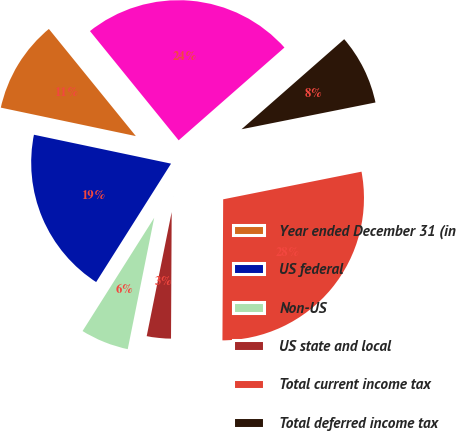<chart> <loc_0><loc_0><loc_500><loc_500><pie_chart><fcel>Year ended December 31 (in<fcel>US federal<fcel>Non-US<fcel>US state and local<fcel>Total current income tax<fcel>Total deferred income tax<fcel>Total income tax expense<nl><fcel>10.84%<fcel>19.33%<fcel>5.81%<fcel>3.08%<fcel>28.22%<fcel>8.32%<fcel>24.39%<nl></chart> 